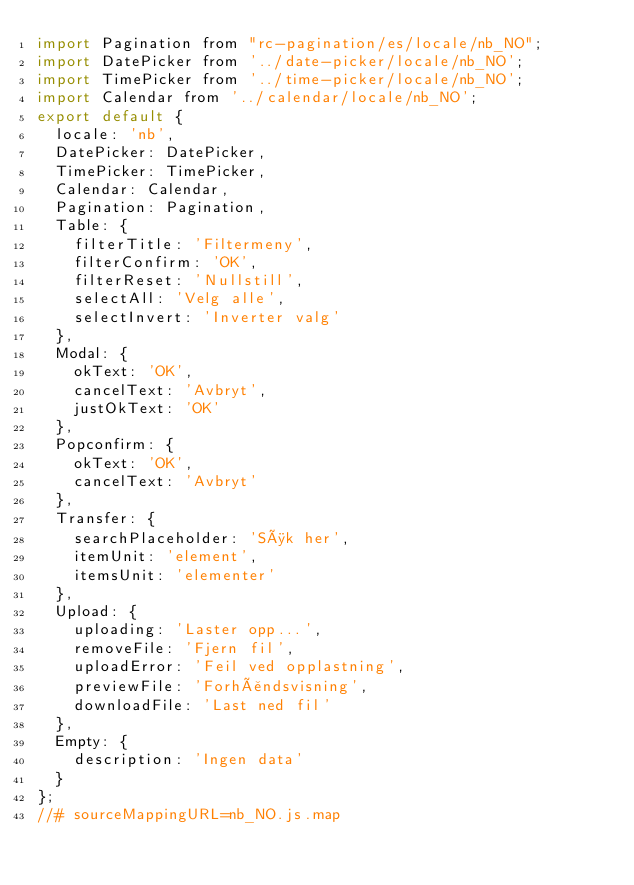Convert code to text. <code><loc_0><loc_0><loc_500><loc_500><_JavaScript_>import Pagination from "rc-pagination/es/locale/nb_NO";
import DatePicker from '../date-picker/locale/nb_NO';
import TimePicker from '../time-picker/locale/nb_NO';
import Calendar from '../calendar/locale/nb_NO';
export default {
  locale: 'nb',
  DatePicker: DatePicker,
  TimePicker: TimePicker,
  Calendar: Calendar,
  Pagination: Pagination,
  Table: {
    filterTitle: 'Filtermeny',
    filterConfirm: 'OK',
    filterReset: 'Nullstill',
    selectAll: 'Velg alle',
    selectInvert: 'Inverter valg'
  },
  Modal: {
    okText: 'OK',
    cancelText: 'Avbryt',
    justOkText: 'OK'
  },
  Popconfirm: {
    okText: 'OK',
    cancelText: 'Avbryt'
  },
  Transfer: {
    searchPlaceholder: 'Søk her',
    itemUnit: 'element',
    itemsUnit: 'elementer'
  },
  Upload: {
    uploading: 'Laster opp...',
    removeFile: 'Fjern fil',
    uploadError: 'Feil ved opplastning',
    previewFile: 'Forhåndsvisning',
    downloadFile: 'Last ned fil'
  },
  Empty: {
    description: 'Ingen data'
  }
};
//# sourceMappingURL=nb_NO.js.map
</code> 